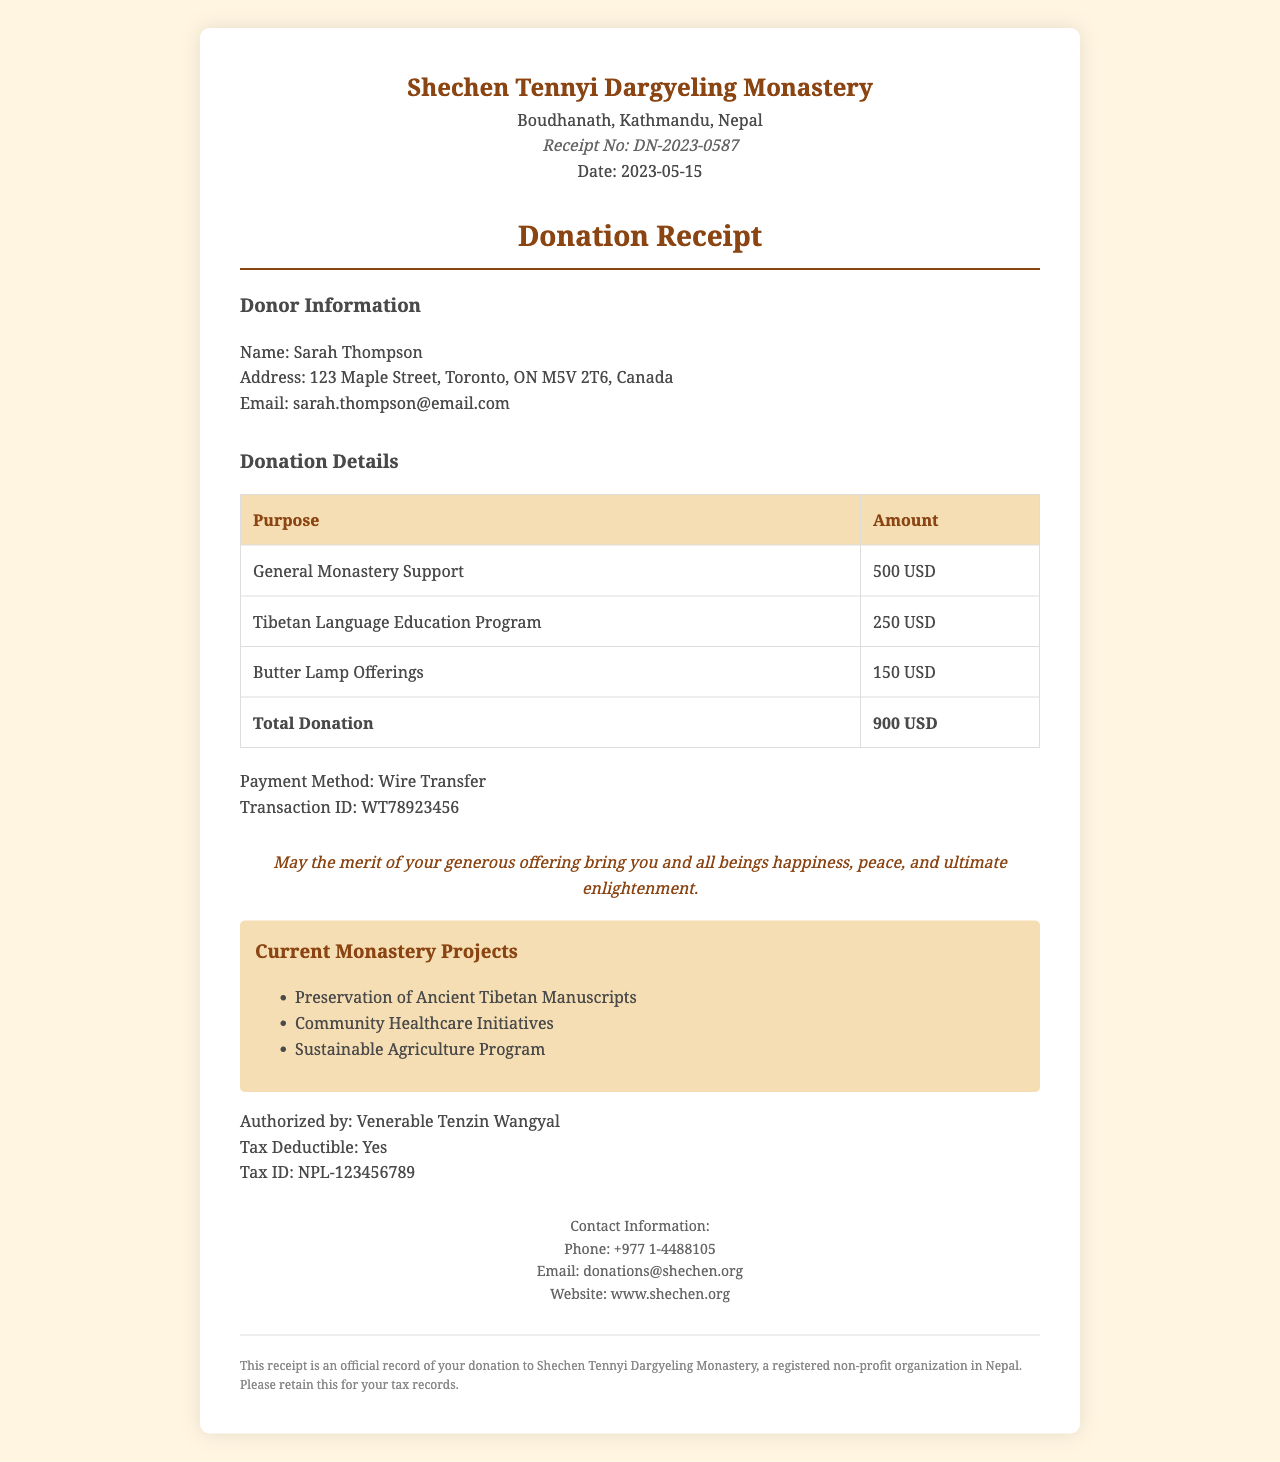What is the monastery's name? The monastery's name is located at the top of the document, specifically listed as "Shechen Tennyi Dargyeling Monastery."
Answer: Shechen Tennyi Dargyeling Monastery What is the total donation amount? The total donation amount is found at the end of the donation details section, which lists the total as $900.
Answer: 900 USD Who is the donor? The donor's name is stated in the donor information section, which mentions "Sarah Thompson."
Answer: Sarah Thompson When was the donation receipt issued? The date of the receipt is specified in the header section, listed as "2023-05-15."
Answer: 2023-05-15 What is the purpose of the largest donation? The largest donation purpose is shown in the donation details, specifically for the amount of $500, which is for "General Monastery Support."
Answer: General Monastery Support Is the donation tax deductible? The tax deductibility status is stated in the footer section of the document, noted as "Yes."
Answer: Yes What is the transaction ID? The transaction ID is provided under the donation details, specifically recorded as "WT78923456."
Answer: WT78923456 Who authorized the receipt? The authorized person is mentioned in the footer section as "Venerable Tenzin Wangyal."
Answer: Venerable Tenzin Wangyal What are the current monastery projects? The current projects are listed in a specific section titled "Current Monastery Projects," which includes multiple projects.
Answer: Preservation of Ancient Tibetan Manuscripts, Community Healthcare Initiatives, Sustainable Agriculture Program 